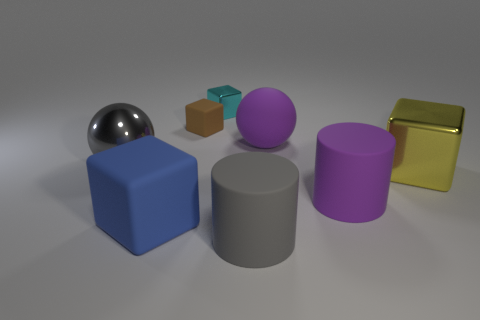What number of brown rubber things have the same shape as the blue matte object?
Your answer should be compact. 1. What size is the purple thing that is in front of the large gray thing that is left of the brown cube?
Your response must be concise. Large. Is the size of the purple sphere the same as the cyan block?
Your answer should be very brief. No. Is there a cyan cube that is behind the sphere behind the big sphere to the left of the large gray cylinder?
Keep it short and to the point. Yes. What is the size of the blue rubber object?
Your answer should be compact. Large. How many other rubber cylinders have the same size as the gray cylinder?
Give a very brief answer. 1. There is a big yellow object that is the same shape as the blue matte object; what is it made of?
Provide a short and direct response. Metal. What is the shape of the shiny thing that is both in front of the tiny brown object and to the right of the blue thing?
Ensure brevity in your answer.  Cube. There is a big gray thing behind the large matte cube; what is its shape?
Provide a short and direct response. Sphere. How many big cubes are on the left side of the tiny metallic thing and right of the tiny cyan shiny block?
Provide a short and direct response. 0. 